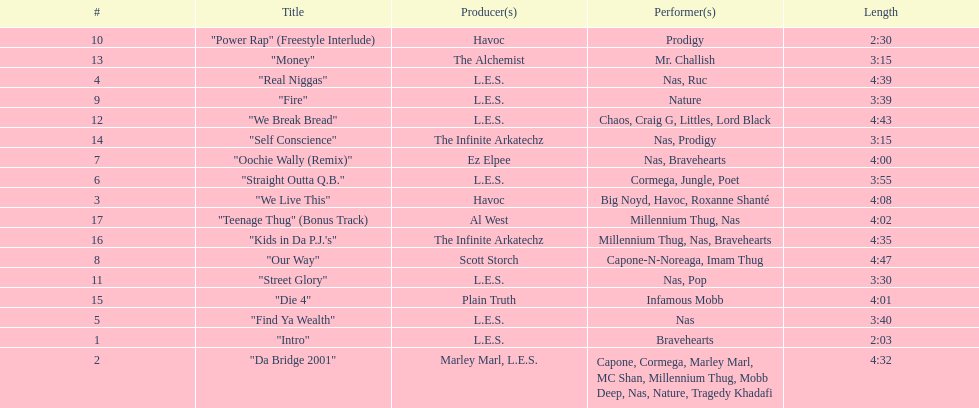What song was performed before "fire"? "Our Way". 